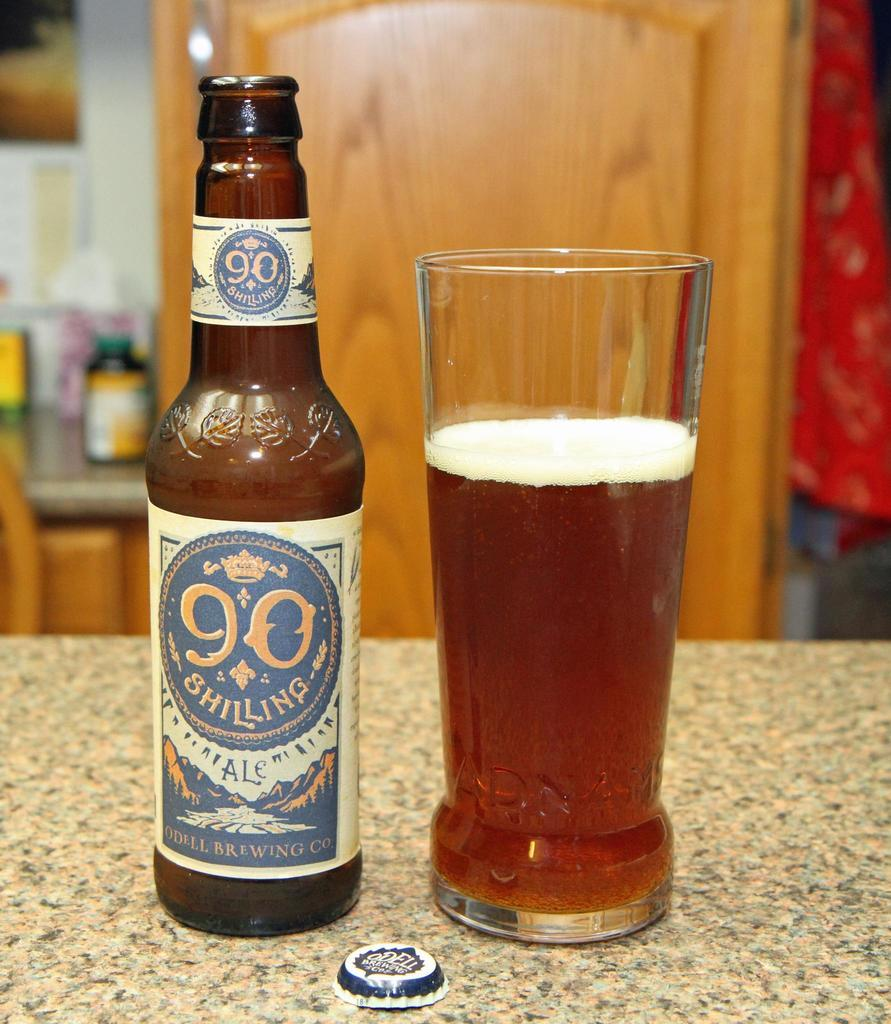<image>
Give a short and clear explanation of the subsequent image. A bottle of Shiling 90 Ale next to a glass three quarters filled with the Ale. 